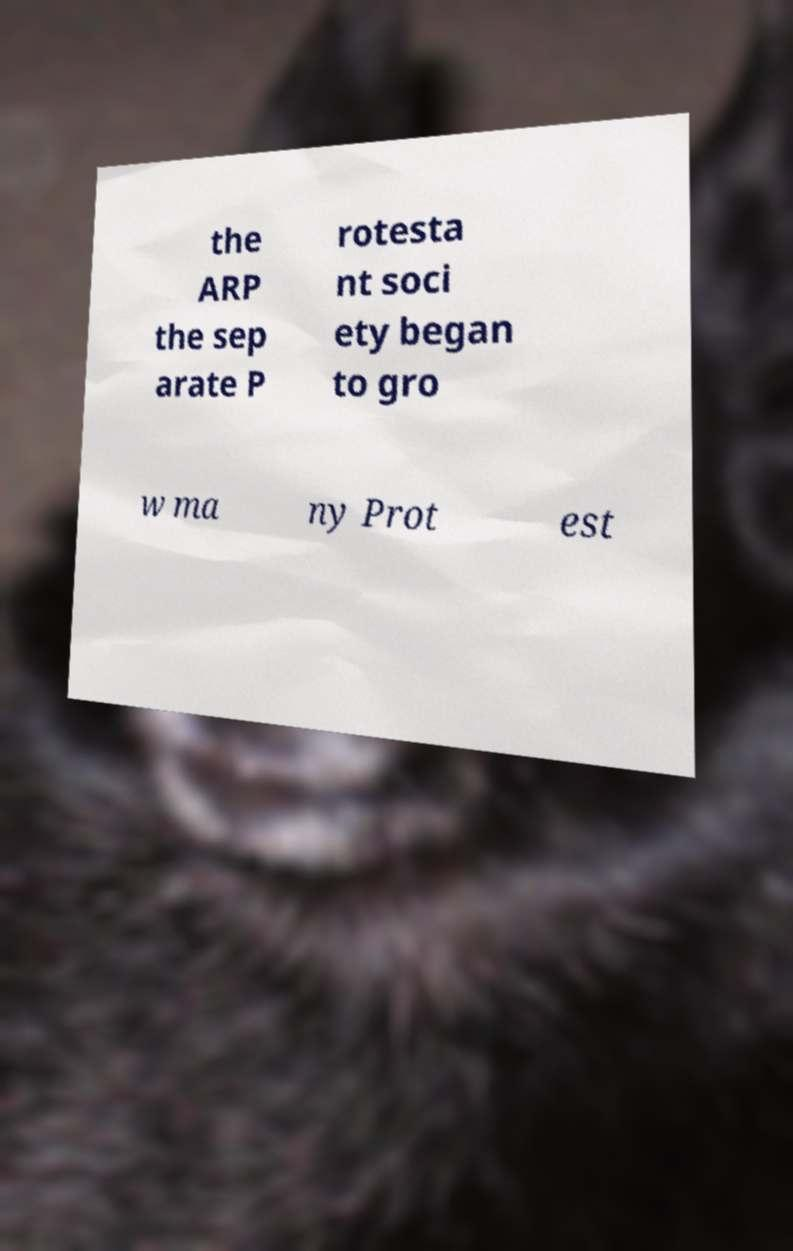What messages or text are displayed in this image? I need them in a readable, typed format. the ARP the sep arate P rotesta nt soci ety began to gro w ma ny Prot est 